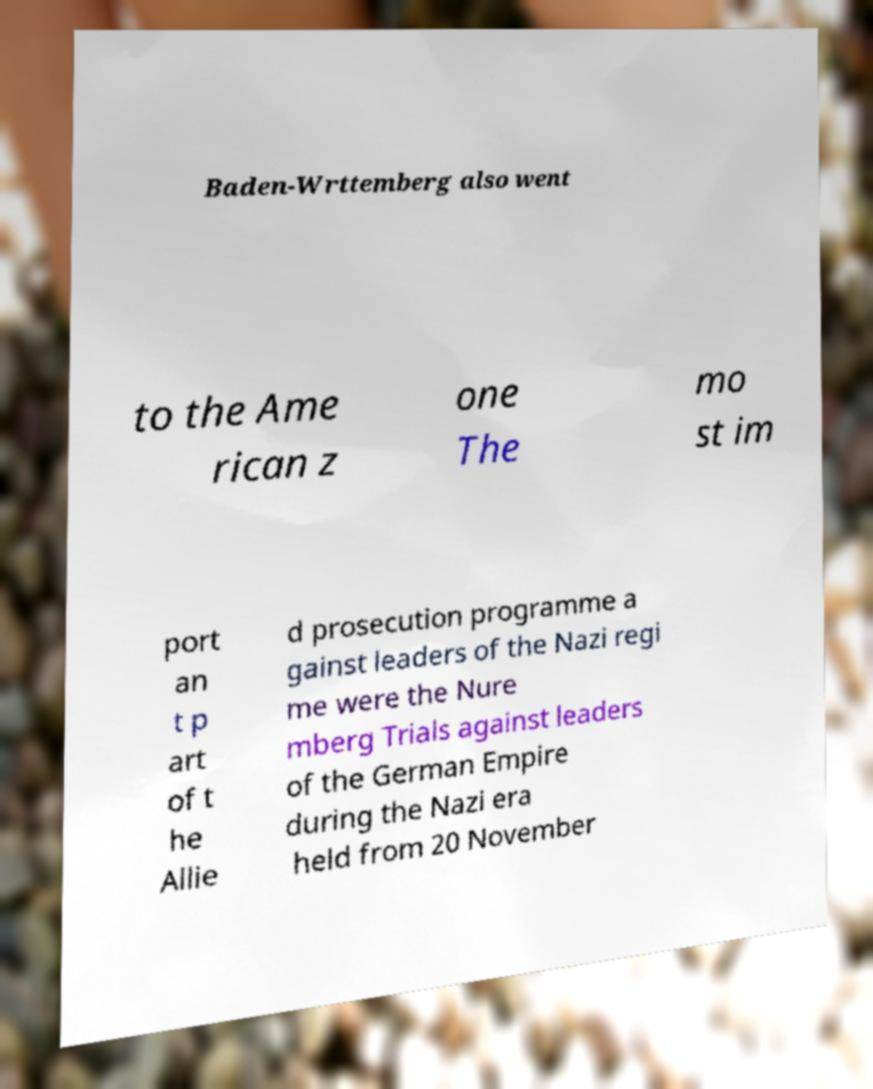There's text embedded in this image that I need extracted. Can you transcribe it verbatim? Baden-Wrttemberg also went to the Ame rican z one The mo st im port an t p art of t he Allie d prosecution programme a gainst leaders of the Nazi regi me were the Nure mberg Trials against leaders of the German Empire during the Nazi era held from 20 November 